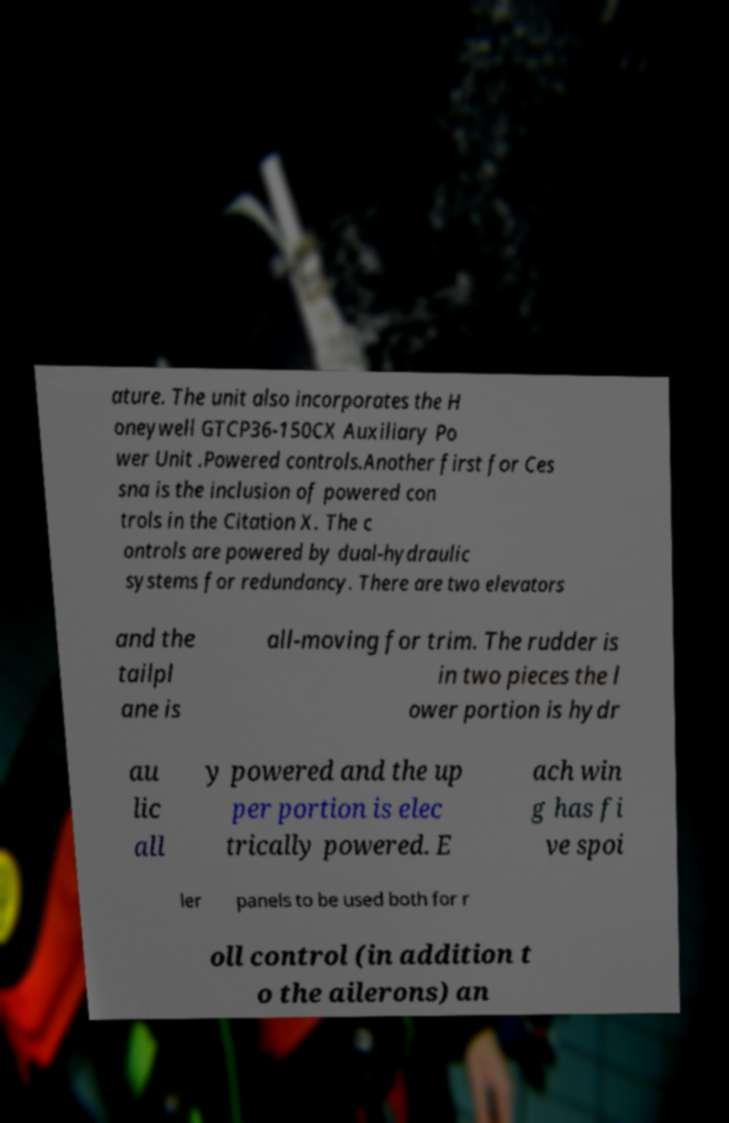For documentation purposes, I need the text within this image transcribed. Could you provide that? ature. The unit also incorporates the H oneywell GTCP36-150CX Auxiliary Po wer Unit .Powered controls.Another first for Ces sna is the inclusion of powered con trols in the Citation X. The c ontrols are powered by dual-hydraulic systems for redundancy. There are two elevators and the tailpl ane is all-moving for trim. The rudder is in two pieces the l ower portion is hydr au lic all y powered and the up per portion is elec trically powered. E ach win g has fi ve spoi ler panels to be used both for r oll control (in addition t o the ailerons) an 